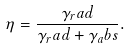Convert formula to latex. <formula><loc_0><loc_0><loc_500><loc_500>\eta = \frac { \gamma _ { r } a d } { \gamma _ { r } a d + \gamma _ { a } b s } .</formula> 